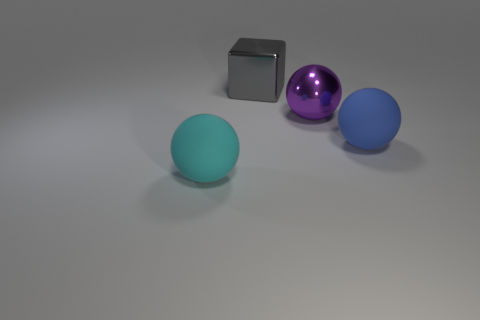How many yellow metallic things have the same shape as the large cyan thing?
Make the answer very short. 0. How many objects are either big blue matte spheres or metallic objects in front of the large gray object?
Give a very brief answer. 2. What is the material of the big purple sphere?
Offer a very short reply. Metal. What is the material of the cyan object that is the same shape as the purple object?
Offer a terse response. Rubber. There is a rubber object that is left of the large rubber sphere behind the large cyan object; what color is it?
Your answer should be compact. Cyan. What number of shiny objects are purple objects or big cyan spheres?
Make the answer very short. 1. Are the big blue object and the big purple thing made of the same material?
Provide a short and direct response. No. There is a big thing that is left of the large metal thing to the left of the purple ball; what is it made of?
Ensure brevity in your answer.  Rubber. What number of large objects are metallic balls or green cylinders?
Your answer should be compact. 1. The shiny cube has what size?
Your response must be concise. Large. 